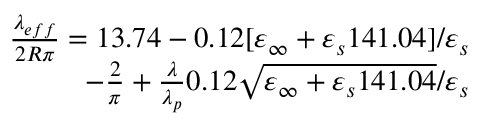Convert formula to latex. <formula><loc_0><loc_0><loc_500><loc_500>\begin{array} { r } { \frac { \lambda _ { e f f } } { 2 R \pi } = 1 3 . 7 4 - 0 . 1 2 [ \varepsilon _ { \infty } + \varepsilon _ { s } 1 4 1 . 0 4 ] / \varepsilon _ { s } } \\ { - \frac { 2 } { \pi } + \frac { \lambda } { \lambda _ { p } } 0 . 1 2 \sqrt { \varepsilon _ { \infty } + \varepsilon _ { s } 1 4 1 . 0 4 } / \varepsilon _ { s } } \end{array}</formula> 